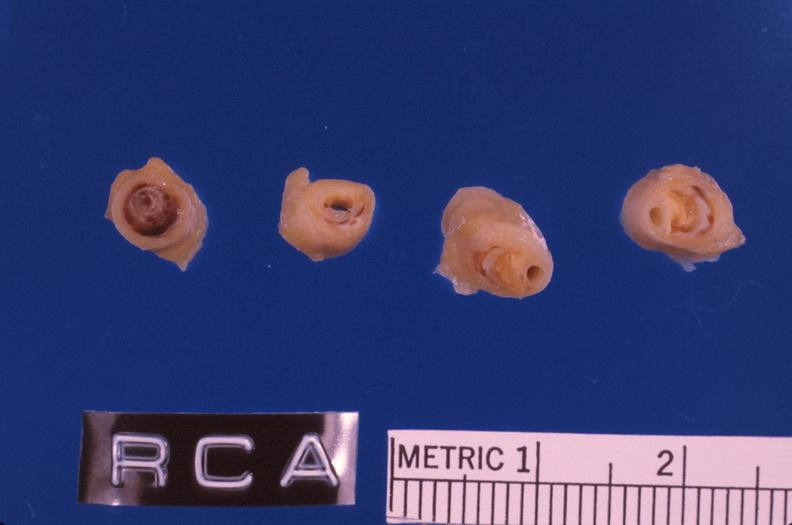does this image show coronary artery atherosclerosis?
Answer the question using a single word or phrase. Yes 